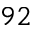<formula> <loc_0><loc_0><loc_500><loc_500>_ { 9 2 }</formula> 